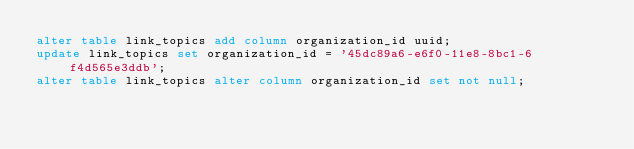<code> <loc_0><loc_0><loc_500><loc_500><_SQL_>alter table link_topics add column organization_id uuid;
update link_topics set organization_id = '45dc89a6-e6f0-11e8-8bc1-6f4d565e3ddb';
alter table link_topics alter column organization_id set not null;
</code> 